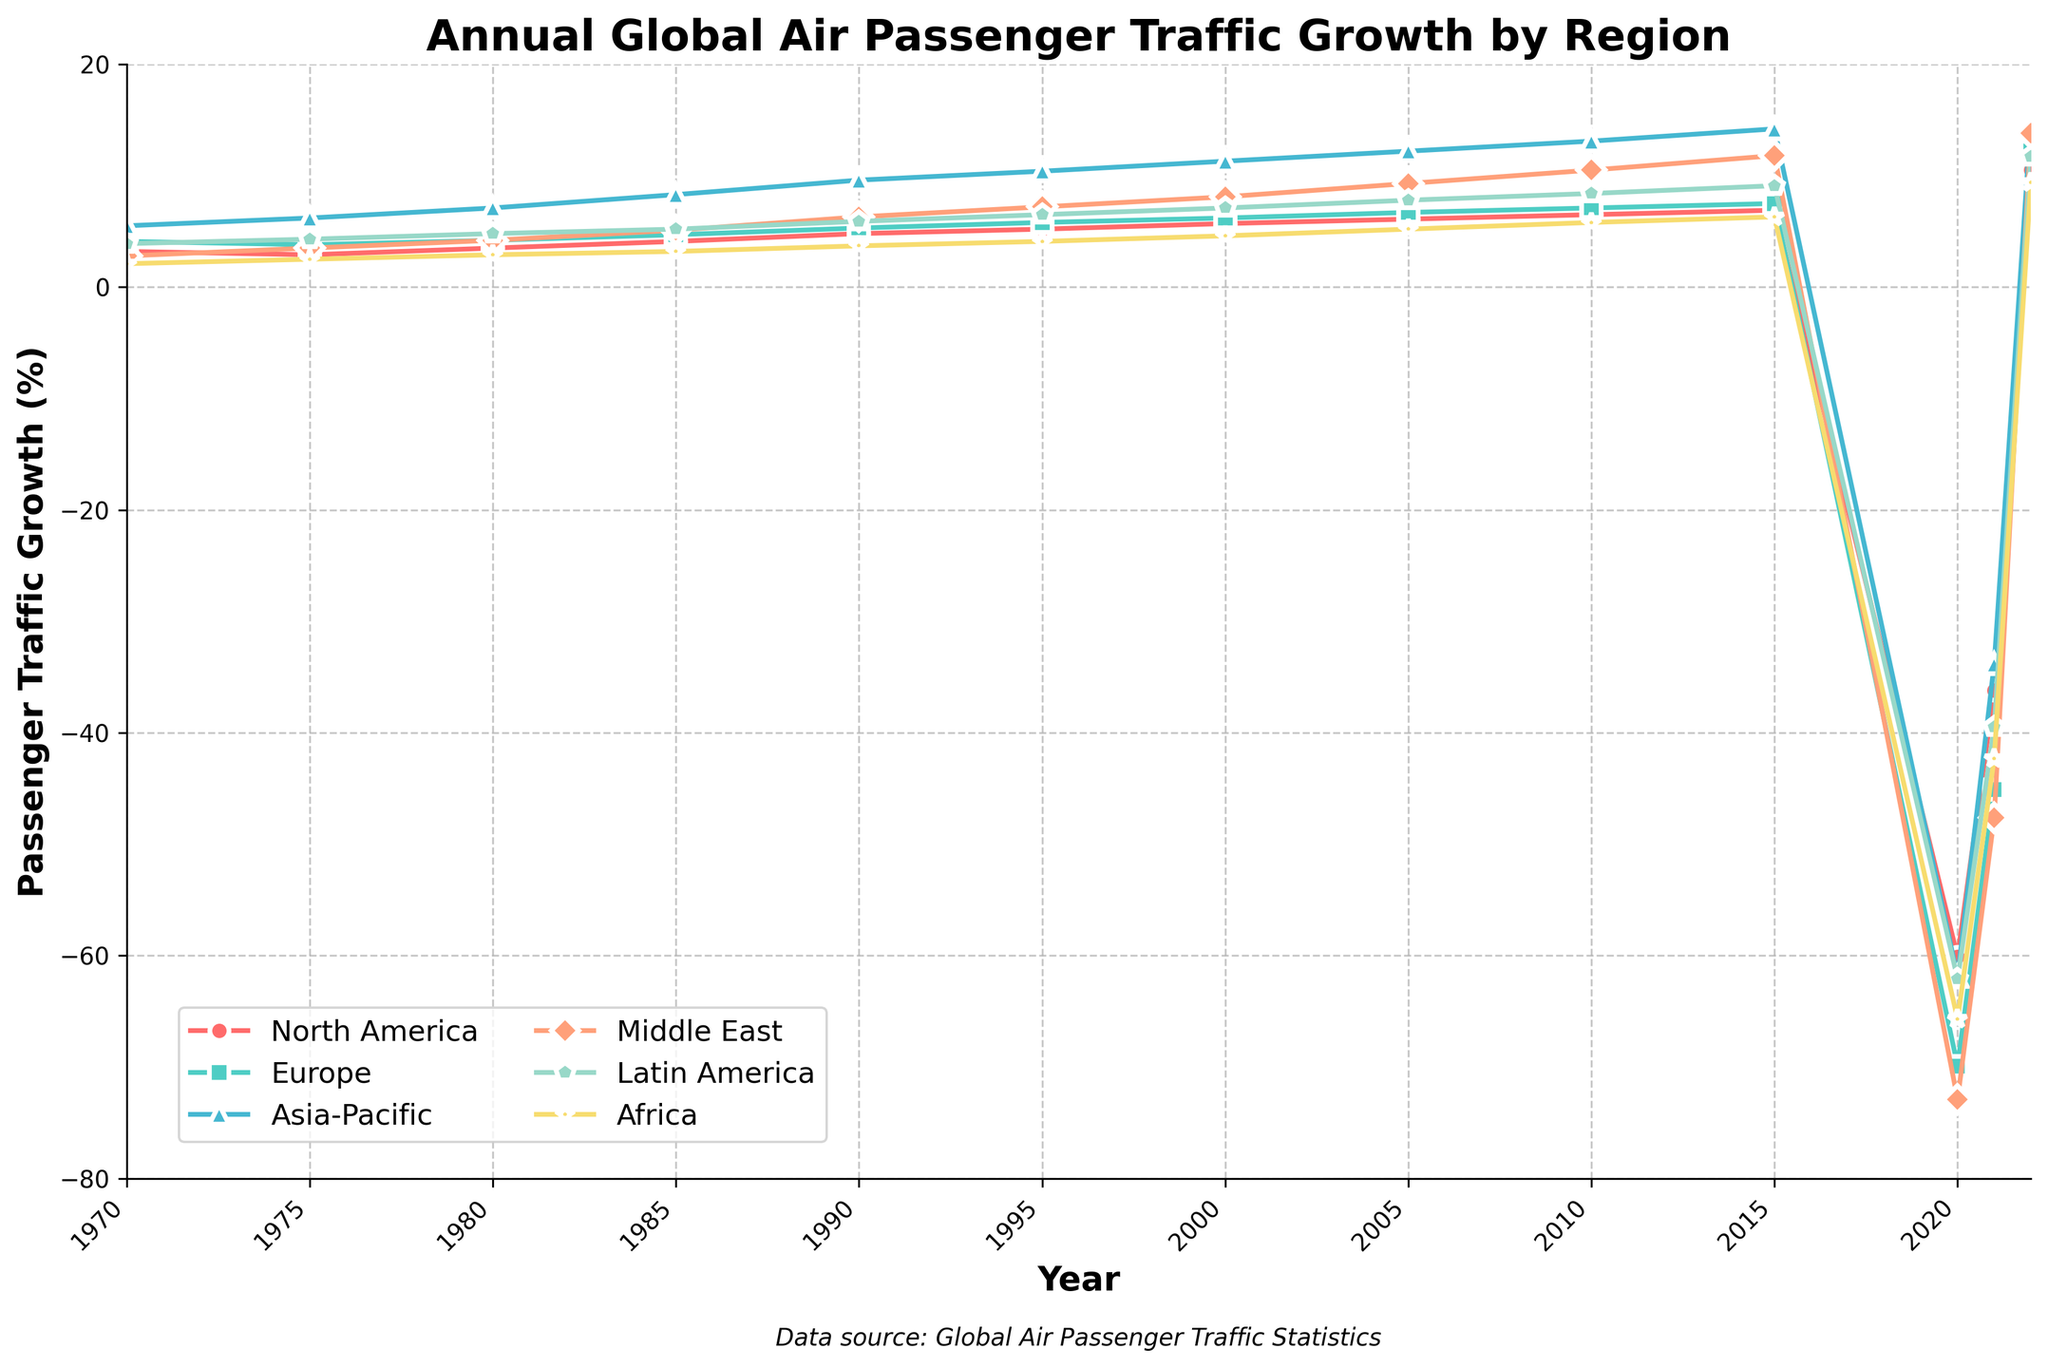Which region had the highest passenger traffic growth in 1990? To determine this, look at the data points for each region in the year 1990. The Middle East has a growth rate of 6.3%, which is the highest among the listed regions.
Answer: Middle East How did North America's passenger traffic growth change from 2019 to 2020? Compare the growth rates of North America for the years 2019 and 2020. In 2019, although not explicitly stated, the growth would be close to the 6.9% seen in 2018 because significant anomalies are rare in consecutive years, but in 2020, it plummets to -60.1%. The change is approximately -67%.
Answer: Decreased by approximately 67% Which region had the steepest decline in passenger traffic growth in 2020? Compare the declines in percentage for all regions in 2020. Europe had the largest drop at -69.9%.
Answer: Europe What is the average passenger traffic growth for Asia-Pacific from 1970 to 2022? Sum all the growth values for Asia-Pacific and divide by the number of years represented. (-3.2 + 3.8 + 4.2 + 5.8 + 6.2 + 6.7 + 7.1 + 7.5 -61.9 - 33.8 + 14.9) / 13 = -1.11.
Answer: -1.11 Between 2010 and 2022, which regions recorded a positive growth rate? Check the values for each region between 2010 and 2022. All regions except Africa registered positive growth rates.
Answer: North America, Europe, Asia-Pacific, Middle East, Latin America In 2021, which region showed the least recovery compared to their decline in 2020? Calculate the amount each region recovered in 2021 from their 2020 decline, then identify the smallest recovery. North America dropped from -60.1% to -36.2%, Europe from -69.9% to -45.1%, Asia-Pacific from -61.9% to -33.8%, Middle East from -72.9% to -47.6%, Latin America from -62.1% to -39.5%, and Africa from -65.7% to -42.3%. The smallest recovery was in Europe.
Answer: Europe Which region experienced the highest traffic growth in 2022? From the 2022 data points, Asia-Pacific experienced the highest traffic growth with 14.9%.
Answer: Asia-Pacific 